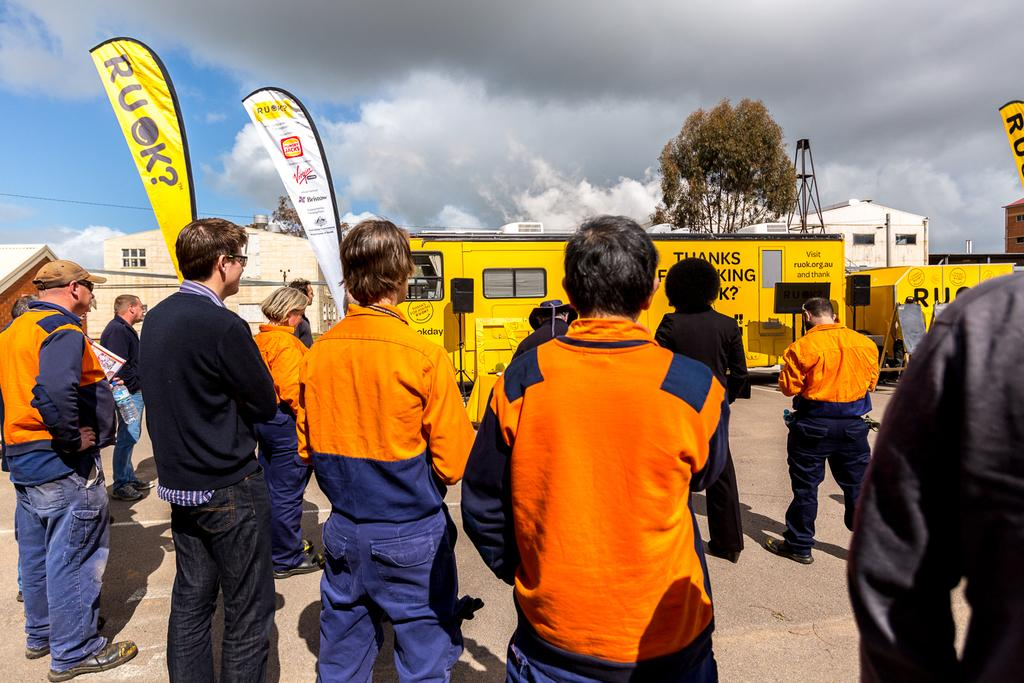What can be seen in the image? There are people standing in the image. What is visible in the background of the image? There are vehicles, houses, trees, and the sky visible in the background of the image. What else can be observed in the image? There are flags in the image with some text on them. What type of beetle can be seen crawling on the text of the flags in the image? There are no beetles present in the image, and therefore no such activity can be observed. 